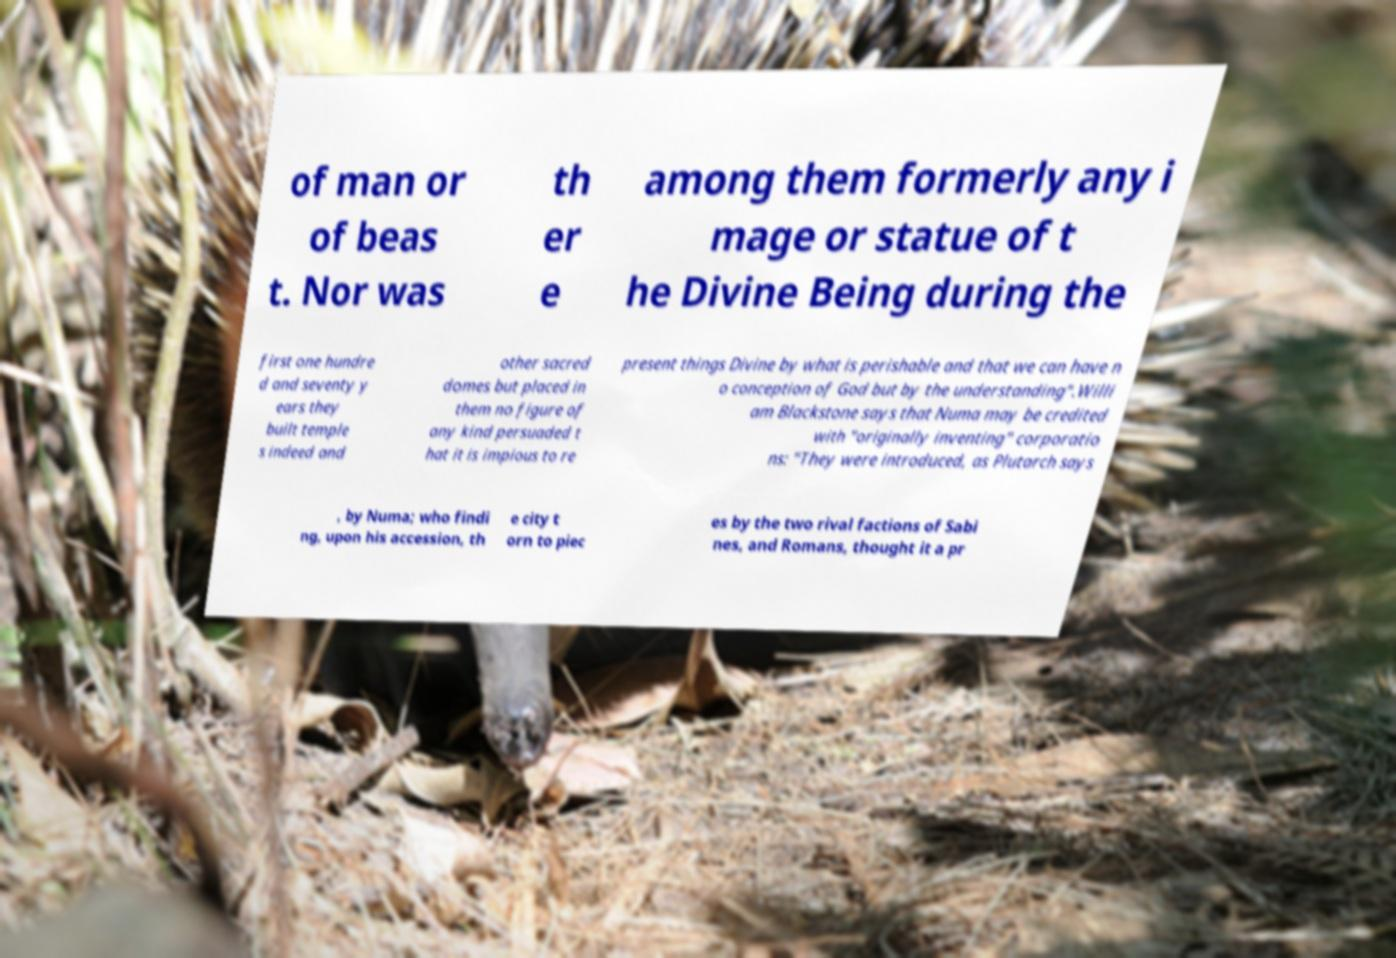Please identify and transcribe the text found in this image. of man or of beas t. Nor was th er e among them formerly any i mage or statue of t he Divine Being during the first one hundre d and seventy y ears they built temple s indeed and other sacred domes but placed in them no figure of any kind persuaded t hat it is impious to re present things Divine by what is perishable and that we can have n o conception of God but by the understanding".Willi am Blackstone says that Numa may be credited with "originally inventing" corporatio ns: "They were introduced, as Plutarch says , by Numa; who findi ng, upon his accession, th e city t orn to piec es by the two rival factions of Sabi nes, and Romans, thought it a pr 